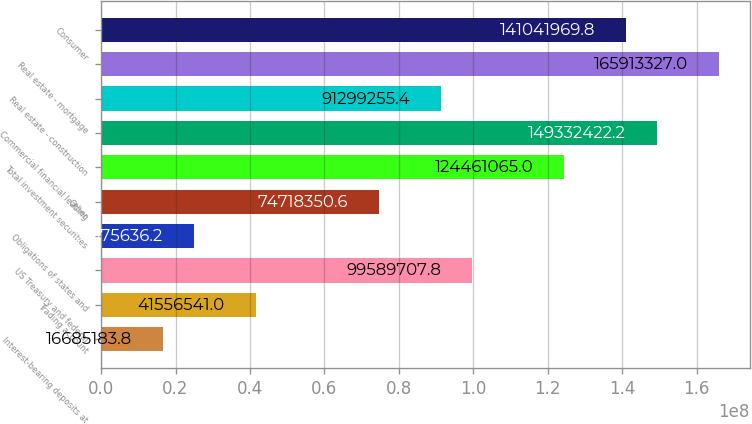Convert chart. <chart><loc_0><loc_0><loc_500><loc_500><bar_chart><fcel>Interest-bearing deposits at<fcel>Trading account<fcel>US Treasury and federal<fcel>Obligations of states and<fcel>Other<fcel>Total investment securities<fcel>Commercial financial leasing<fcel>Real estate - construction<fcel>Real estate - mortgage<fcel>Consumer<nl><fcel>1.66852e+07<fcel>4.15565e+07<fcel>9.95897e+07<fcel>2.49756e+07<fcel>7.47184e+07<fcel>1.24461e+08<fcel>1.49332e+08<fcel>9.12993e+07<fcel>1.65913e+08<fcel>1.41042e+08<nl></chart> 